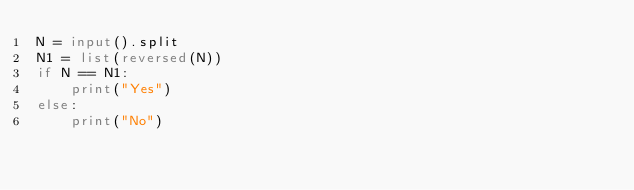<code> <loc_0><loc_0><loc_500><loc_500><_Python_>N = input().split
N1 = list(reversed(N))
if N == N1:
    print("Yes")
else:
    print("No")</code> 